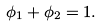<formula> <loc_0><loc_0><loc_500><loc_500>\phi _ { 1 } + \phi _ { 2 } = 1 .</formula> 